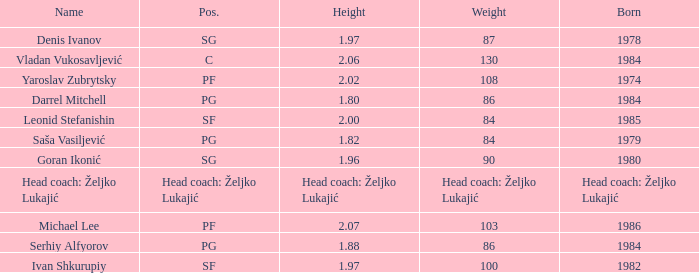Which position did Michael Lee play? PF. 